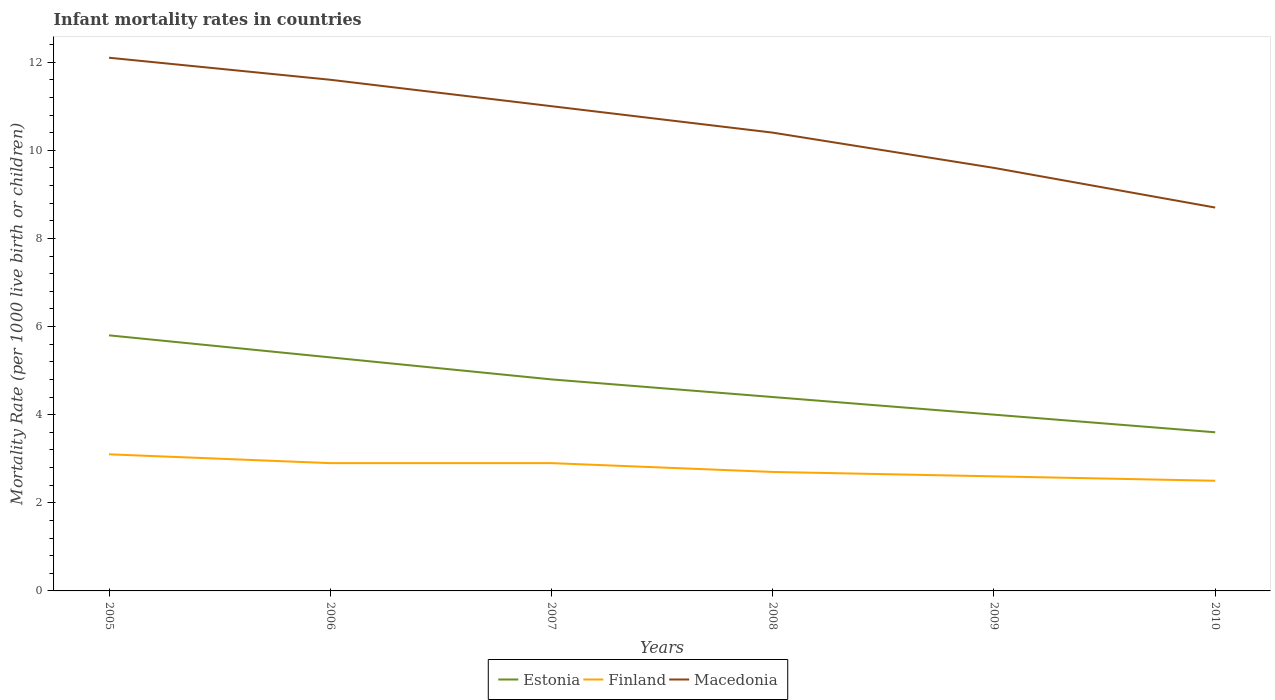How many different coloured lines are there?
Provide a short and direct response. 3. In which year was the infant mortality rate in Macedonia maximum?
Give a very brief answer. 2010. What is the total infant mortality rate in Finland in the graph?
Make the answer very short. 0.4. What is the difference between the highest and the second highest infant mortality rate in Finland?
Offer a very short reply. 0.6. What is the difference between two consecutive major ticks on the Y-axis?
Provide a succinct answer. 2. Does the graph contain any zero values?
Make the answer very short. No. Does the graph contain grids?
Your answer should be very brief. No. Where does the legend appear in the graph?
Your answer should be very brief. Bottom center. How are the legend labels stacked?
Keep it short and to the point. Horizontal. What is the title of the graph?
Give a very brief answer. Infant mortality rates in countries. What is the label or title of the X-axis?
Your answer should be compact. Years. What is the label or title of the Y-axis?
Provide a succinct answer. Mortality Rate (per 1000 live birth or children). What is the Mortality Rate (per 1000 live birth or children) in Finland in 2005?
Your answer should be very brief. 3.1. What is the Mortality Rate (per 1000 live birth or children) in Macedonia in 2005?
Your answer should be very brief. 12.1. What is the Mortality Rate (per 1000 live birth or children) in Finland in 2006?
Make the answer very short. 2.9. What is the Mortality Rate (per 1000 live birth or children) in Finland in 2007?
Provide a short and direct response. 2.9. What is the Mortality Rate (per 1000 live birth or children) in Macedonia in 2009?
Your response must be concise. 9.6. What is the Mortality Rate (per 1000 live birth or children) in Estonia in 2010?
Ensure brevity in your answer.  3.6. What is the Mortality Rate (per 1000 live birth or children) of Finland in 2010?
Your response must be concise. 2.5. Across all years, what is the maximum Mortality Rate (per 1000 live birth or children) in Estonia?
Your answer should be compact. 5.8. Across all years, what is the maximum Mortality Rate (per 1000 live birth or children) of Macedonia?
Offer a very short reply. 12.1. What is the total Mortality Rate (per 1000 live birth or children) in Estonia in the graph?
Keep it short and to the point. 27.9. What is the total Mortality Rate (per 1000 live birth or children) of Finland in the graph?
Give a very brief answer. 16.7. What is the total Mortality Rate (per 1000 live birth or children) of Macedonia in the graph?
Offer a very short reply. 63.4. What is the difference between the Mortality Rate (per 1000 live birth or children) in Estonia in 2005 and that in 2006?
Your answer should be compact. 0.5. What is the difference between the Mortality Rate (per 1000 live birth or children) of Finland in 2005 and that in 2006?
Provide a short and direct response. 0.2. What is the difference between the Mortality Rate (per 1000 live birth or children) in Macedonia in 2005 and that in 2006?
Ensure brevity in your answer.  0.5. What is the difference between the Mortality Rate (per 1000 live birth or children) of Estonia in 2005 and that in 2007?
Make the answer very short. 1. What is the difference between the Mortality Rate (per 1000 live birth or children) of Macedonia in 2005 and that in 2007?
Give a very brief answer. 1.1. What is the difference between the Mortality Rate (per 1000 live birth or children) of Finland in 2005 and that in 2008?
Your response must be concise. 0.4. What is the difference between the Mortality Rate (per 1000 live birth or children) in Macedonia in 2005 and that in 2008?
Provide a short and direct response. 1.7. What is the difference between the Mortality Rate (per 1000 live birth or children) in Estonia in 2005 and that in 2009?
Give a very brief answer. 1.8. What is the difference between the Mortality Rate (per 1000 live birth or children) of Finland in 2005 and that in 2009?
Your response must be concise. 0.5. What is the difference between the Mortality Rate (per 1000 live birth or children) in Estonia in 2005 and that in 2010?
Your answer should be compact. 2.2. What is the difference between the Mortality Rate (per 1000 live birth or children) of Estonia in 2006 and that in 2007?
Ensure brevity in your answer.  0.5. What is the difference between the Mortality Rate (per 1000 live birth or children) of Macedonia in 2006 and that in 2007?
Keep it short and to the point. 0.6. What is the difference between the Mortality Rate (per 1000 live birth or children) in Estonia in 2006 and that in 2008?
Offer a terse response. 0.9. What is the difference between the Mortality Rate (per 1000 live birth or children) in Finland in 2006 and that in 2008?
Your answer should be very brief. 0.2. What is the difference between the Mortality Rate (per 1000 live birth or children) in Estonia in 2006 and that in 2009?
Your response must be concise. 1.3. What is the difference between the Mortality Rate (per 1000 live birth or children) of Finland in 2006 and that in 2009?
Give a very brief answer. 0.3. What is the difference between the Mortality Rate (per 1000 live birth or children) in Macedonia in 2006 and that in 2009?
Ensure brevity in your answer.  2. What is the difference between the Mortality Rate (per 1000 live birth or children) in Estonia in 2006 and that in 2010?
Your response must be concise. 1.7. What is the difference between the Mortality Rate (per 1000 live birth or children) of Finland in 2006 and that in 2010?
Give a very brief answer. 0.4. What is the difference between the Mortality Rate (per 1000 live birth or children) of Estonia in 2007 and that in 2008?
Your response must be concise. 0.4. What is the difference between the Mortality Rate (per 1000 live birth or children) of Estonia in 2007 and that in 2009?
Keep it short and to the point. 0.8. What is the difference between the Mortality Rate (per 1000 live birth or children) in Finland in 2007 and that in 2009?
Your response must be concise. 0.3. What is the difference between the Mortality Rate (per 1000 live birth or children) in Macedonia in 2007 and that in 2009?
Ensure brevity in your answer.  1.4. What is the difference between the Mortality Rate (per 1000 live birth or children) of Estonia in 2007 and that in 2010?
Give a very brief answer. 1.2. What is the difference between the Mortality Rate (per 1000 live birth or children) in Macedonia in 2007 and that in 2010?
Provide a succinct answer. 2.3. What is the difference between the Mortality Rate (per 1000 live birth or children) in Estonia in 2008 and that in 2010?
Your answer should be compact. 0.8. What is the difference between the Mortality Rate (per 1000 live birth or children) in Finland in 2008 and that in 2010?
Ensure brevity in your answer.  0.2. What is the difference between the Mortality Rate (per 1000 live birth or children) of Estonia in 2009 and that in 2010?
Make the answer very short. 0.4. What is the difference between the Mortality Rate (per 1000 live birth or children) of Finland in 2009 and that in 2010?
Give a very brief answer. 0.1. What is the difference between the Mortality Rate (per 1000 live birth or children) of Finland in 2005 and the Mortality Rate (per 1000 live birth or children) of Macedonia in 2006?
Keep it short and to the point. -8.5. What is the difference between the Mortality Rate (per 1000 live birth or children) of Estonia in 2005 and the Mortality Rate (per 1000 live birth or children) of Finland in 2007?
Make the answer very short. 2.9. What is the difference between the Mortality Rate (per 1000 live birth or children) in Estonia in 2005 and the Mortality Rate (per 1000 live birth or children) in Macedonia in 2007?
Keep it short and to the point. -5.2. What is the difference between the Mortality Rate (per 1000 live birth or children) of Finland in 2005 and the Mortality Rate (per 1000 live birth or children) of Macedonia in 2007?
Give a very brief answer. -7.9. What is the difference between the Mortality Rate (per 1000 live birth or children) of Estonia in 2005 and the Mortality Rate (per 1000 live birth or children) of Macedonia in 2008?
Your response must be concise. -4.6. What is the difference between the Mortality Rate (per 1000 live birth or children) of Estonia in 2005 and the Mortality Rate (per 1000 live birth or children) of Macedonia in 2009?
Your response must be concise. -3.8. What is the difference between the Mortality Rate (per 1000 live birth or children) of Estonia in 2005 and the Mortality Rate (per 1000 live birth or children) of Macedonia in 2010?
Offer a terse response. -2.9. What is the difference between the Mortality Rate (per 1000 live birth or children) in Finland in 2005 and the Mortality Rate (per 1000 live birth or children) in Macedonia in 2010?
Keep it short and to the point. -5.6. What is the difference between the Mortality Rate (per 1000 live birth or children) in Estonia in 2006 and the Mortality Rate (per 1000 live birth or children) in Macedonia in 2007?
Ensure brevity in your answer.  -5.7. What is the difference between the Mortality Rate (per 1000 live birth or children) of Finland in 2006 and the Mortality Rate (per 1000 live birth or children) of Macedonia in 2007?
Make the answer very short. -8.1. What is the difference between the Mortality Rate (per 1000 live birth or children) of Estonia in 2006 and the Mortality Rate (per 1000 live birth or children) of Macedonia in 2008?
Your answer should be very brief. -5.1. What is the difference between the Mortality Rate (per 1000 live birth or children) of Finland in 2006 and the Mortality Rate (per 1000 live birth or children) of Macedonia in 2008?
Give a very brief answer. -7.5. What is the difference between the Mortality Rate (per 1000 live birth or children) in Estonia in 2006 and the Mortality Rate (per 1000 live birth or children) in Finland in 2009?
Give a very brief answer. 2.7. What is the difference between the Mortality Rate (per 1000 live birth or children) of Finland in 2006 and the Mortality Rate (per 1000 live birth or children) of Macedonia in 2010?
Offer a very short reply. -5.8. What is the difference between the Mortality Rate (per 1000 live birth or children) in Finland in 2007 and the Mortality Rate (per 1000 live birth or children) in Macedonia in 2009?
Provide a succinct answer. -6.7. What is the difference between the Mortality Rate (per 1000 live birth or children) of Finland in 2007 and the Mortality Rate (per 1000 live birth or children) of Macedonia in 2010?
Offer a terse response. -5.8. What is the difference between the Mortality Rate (per 1000 live birth or children) of Estonia in 2008 and the Mortality Rate (per 1000 live birth or children) of Finland in 2009?
Keep it short and to the point. 1.8. What is the difference between the Mortality Rate (per 1000 live birth or children) in Estonia in 2008 and the Mortality Rate (per 1000 live birth or children) in Finland in 2010?
Offer a very short reply. 1.9. What is the difference between the Mortality Rate (per 1000 live birth or children) in Estonia in 2008 and the Mortality Rate (per 1000 live birth or children) in Macedonia in 2010?
Make the answer very short. -4.3. What is the difference between the Mortality Rate (per 1000 live birth or children) of Estonia in 2009 and the Mortality Rate (per 1000 live birth or children) of Finland in 2010?
Provide a succinct answer. 1.5. What is the difference between the Mortality Rate (per 1000 live birth or children) of Estonia in 2009 and the Mortality Rate (per 1000 live birth or children) of Macedonia in 2010?
Ensure brevity in your answer.  -4.7. What is the difference between the Mortality Rate (per 1000 live birth or children) of Finland in 2009 and the Mortality Rate (per 1000 live birth or children) of Macedonia in 2010?
Provide a succinct answer. -6.1. What is the average Mortality Rate (per 1000 live birth or children) in Estonia per year?
Your answer should be very brief. 4.65. What is the average Mortality Rate (per 1000 live birth or children) of Finland per year?
Your response must be concise. 2.78. What is the average Mortality Rate (per 1000 live birth or children) in Macedonia per year?
Your response must be concise. 10.57. In the year 2005, what is the difference between the Mortality Rate (per 1000 live birth or children) of Estonia and Mortality Rate (per 1000 live birth or children) of Finland?
Offer a terse response. 2.7. In the year 2006, what is the difference between the Mortality Rate (per 1000 live birth or children) of Estonia and Mortality Rate (per 1000 live birth or children) of Macedonia?
Your answer should be very brief. -6.3. In the year 2007, what is the difference between the Mortality Rate (per 1000 live birth or children) of Estonia and Mortality Rate (per 1000 live birth or children) of Finland?
Offer a terse response. 1.9. In the year 2007, what is the difference between the Mortality Rate (per 1000 live birth or children) in Estonia and Mortality Rate (per 1000 live birth or children) in Macedonia?
Offer a terse response. -6.2. In the year 2007, what is the difference between the Mortality Rate (per 1000 live birth or children) in Finland and Mortality Rate (per 1000 live birth or children) in Macedonia?
Make the answer very short. -8.1. In the year 2008, what is the difference between the Mortality Rate (per 1000 live birth or children) of Estonia and Mortality Rate (per 1000 live birth or children) of Macedonia?
Make the answer very short. -6. In the year 2008, what is the difference between the Mortality Rate (per 1000 live birth or children) of Finland and Mortality Rate (per 1000 live birth or children) of Macedonia?
Give a very brief answer. -7.7. In the year 2009, what is the difference between the Mortality Rate (per 1000 live birth or children) in Finland and Mortality Rate (per 1000 live birth or children) in Macedonia?
Your answer should be compact. -7. In the year 2010, what is the difference between the Mortality Rate (per 1000 live birth or children) in Estonia and Mortality Rate (per 1000 live birth or children) in Macedonia?
Your answer should be very brief. -5.1. What is the ratio of the Mortality Rate (per 1000 live birth or children) of Estonia in 2005 to that in 2006?
Your response must be concise. 1.09. What is the ratio of the Mortality Rate (per 1000 live birth or children) of Finland in 2005 to that in 2006?
Offer a terse response. 1.07. What is the ratio of the Mortality Rate (per 1000 live birth or children) in Macedonia in 2005 to that in 2006?
Your answer should be very brief. 1.04. What is the ratio of the Mortality Rate (per 1000 live birth or children) in Estonia in 2005 to that in 2007?
Keep it short and to the point. 1.21. What is the ratio of the Mortality Rate (per 1000 live birth or children) of Finland in 2005 to that in 2007?
Keep it short and to the point. 1.07. What is the ratio of the Mortality Rate (per 1000 live birth or children) in Macedonia in 2005 to that in 2007?
Make the answer very short. 1.1. What is the ratio of the Mortality Rate (per 1000 live birth or children) of Estonia in 2005 to that in 2008?
Your response must be concise. 1.32. What is the ratio of the Mortality Rate (per 1000 live birth or children) in Finland in 2005 to that in 2008?
Keep it short and to the point. 1.15. What is the ratio of the Mortality Rate (per 1000 live birth or children) in Macedonia in 2005 to that in 2008?
Keep it short and to the point. 1.16. What is the ratio of the Mortality Rate (per 1000 live birth or children) of Estonia in 2005 to that in 2009?
Offer a very short reply. 1.45. What is the ratio of the Mortality Rate (per 1000 live birth or children) of Finland in 2005 to that in 2009?
Offer a terse response. 1.19. What is the ratio of the Mortality Rate (per 1000 live birth or children) in Macedonia in 2005 to that in 2009?
Offer a terse response. 1.26. What is the ratio of the Mortality Rate (per 1000 live birth or children) of Estonia in 2005 to that in 2010?
Ensure brevity in your answer.  1.61. What is the ratio of the Mortality Rate (per 1000 live birth or children) in Finland in 2005 to that in 2010?
Offer a very short reply. 1.24. What is the ratio of the Mortality Rate (per 1000 live birth or children) of Macedonia in 2005 to that in 2010?
Offer a very short reply. 1.39. What is the ratio of the Mortality Rate (per 1000 live birth or children) of Estonia in 2006 to that in 2007?
Offer a very short reply. 1.1. What is the ratio of the Mortality Rate (per 1000 live birth or children) of Finland in 2006 to that in 2007?
Your response must be concise. 1. What is the ratio of the Mortality Rate (per 1000 live birth or children) in Macedonia in 2006 to that in 2007?
Keep it short and to the point. 1.05. What is the ratio of the Mortality Rate (per 1000 live birth or children) in Estonia in 2006 to that in 2008?
Provide a succinct answer. 1.2. What is the ratio of the Mortality Rate (per 1000 live birth or children) in Finland in 2006 to that in 2008?
Offer a terse response. 1.07. What is the ratio of the Mortality Rate (per 1000 live birth or children) in Macedonia in 2006 to that in 2008?
Provide a short and direct response. 1.12. What is the ratio of the Mortality Rate (per 1000 live birth or children) of Estonia in 2006 to that in 2009?
Ensure brevity in your answer.  1.32. What is the ratio of the Mortality Rate (per 1000 live birth or children) in Finland in 2006 to that in 2009?
Offer a terse response. 1.12. What is the ratio of the Mortality Rate (per 1000 live birth or children) in Macedonia in 2006 to that in 2009?
Make the answer very short. 1.21. What is the ratio of the Mortality Rate (per 1000 live birth or children) in Estonia in 2006 to that in 2010?
Keep it short and to the point. 1.47. What is the ratio of the Mortality Rate (per 1000 live birth or children) in Finland in 2006 to that in 2010?
Provide a short and direct response. 1.16. What is the ratio of the Mortality Rate (per 1000 live birth or children) of Macedonia in 2006 to that in 2010?
Provide a succinct answer. 1.33. What is the ratio of the Mortality Rate (per 1000 live birth or children) in Estonia in 2007 to that in 2008?
Provide a short and direct response. 1.09. What is the ratio of the Mortality Rate (per 1000 live birth or children) of Finland in 2007 to that in 2008?
Offer a very short reply. 1.07. What is the ratio of the Mortality Rate (per 1000 live birth or children) in Macedonia in 2007 to that in 2008?
Ensure brevity in your answer.  1.06. What is the ratio of the Mortality Rate (per 1000 live birth or children) in Finland in 2007 to that in 2009?
Your answer should be very brief. 1.12. What is the ratio of the Mortality Rate (per 1000 live birth or children) in Macedonia in 2007 to that in 2009?
Your answer should be very brief. 1.15. What is the ratio of the Mortality Rate (per 1000 live birth or children) in Finland in 2007 to that in 2010?
Keep it short and to the point. 1.16. What is the ratio of the Mortality Rate (per 1000 live birth or children) of Macedonia in 2007 to that in 2010?
Provide a short and direct response. 1.26. What is the ratio of the Mortality Rate (per 1000 live birth or children) in Finland in 2008 to that in 2009?
Provide a short and direct response. 1.04. What is the ratio of the Mortality Rate (per 1000 live birth or children) of Macedonia in 2008 to that in 2009?
Offer a very short reply. 1.08. What is the ratio of the Mortality Rate (per 1000 live birth or children) of Estonia in 2008 to that in 2010?
Provide a succinct answer. 1.22. What is the ratio of the Mortality Rate (per 1000 live birth or children) of Macedonia in 2008 to that in 2010?
Provide a succinct answer. 1.2. What is the ratio of the Mortality Rate (per 1000 live birth or children) of Finland in 2009 to that in 2010?
Offer a very short reply. 1.04. What is the ratio of the Mortality Rate (per 1000 live birth or children) in Macedonia in 2009 to that in 2010?
Your response must be concise. 1.1. What is the difference between the highest and the lowest Mortality Rate (per 1000 live birth or children) of Estonia?
Keep it short and to the point. 2.2. What is the difference between the highest and the lowest Mortality Rate (per 1000 live birth or children) of Finland?
Give a very brief answer. 0.6. 